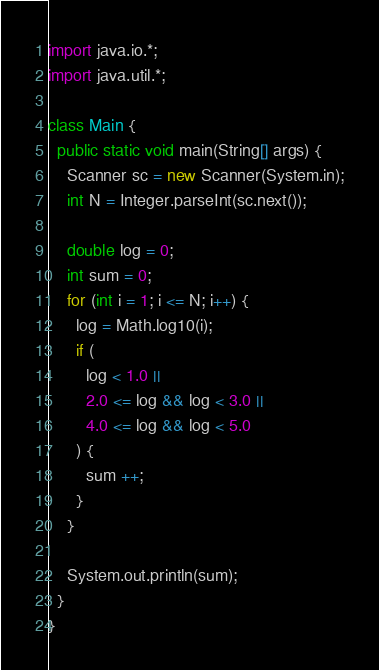Convert code to text. <code><loc_0><loc_0><loc_500><loc_500><_Java_>import java.io.*;
import java.util.*;

class Main {
  public static void main(String[] args) {
    Scanner sc = new Scanner(System.in);
    int N = Integer.parseInt(sc.next());
    
    double log = 0;
    int sum = 0;
    for (int i = 1; i <= N; i++) {
      log = Math.log10(i);
      if (
        log < 1.0 || 
        2.0 <= log && log < 3.0 ||
        4.0 <= log && log < 5.0
      ) {
        sum ++;
      }
    }
    
    System.out.println(sum);
  }
}</code> 